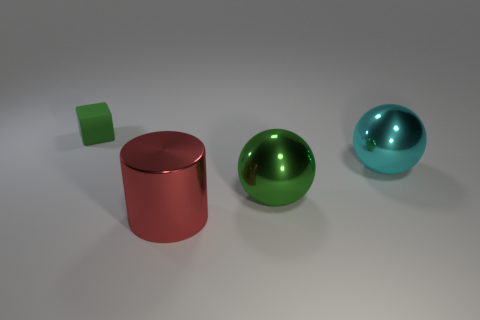Is there any other thing that has the same material as the tiny thing?
Your response must be concise. No. Is the green thing right of the tiny green block made of the same material as the red cylinder?
Offer a very short reply. Yes. There is a big thing in front of the green object on the right side of the small green rubber cube; what is its material?
Offer a very short reply. Metal. How many green matte things have the same shape as the large cyan object?
Your answer should be very brief. 0. What size is the green thing that is in front of the sphere right of the green object on the right side of the red cylinder?
Keep it short and to the point. Large. What number of purple objects are either big metallic spheres or large cylinders?
Offer a terse response. 0. There is a green thing to the right of the rubber object; does it have the same shape as the matte thing?
Provide a succinct answer. No. Is the number of green things to the right of the red cylinder greater than the number of small brown cubes?
Provide a succinct answer. Yes. How many metallic objects are the same size as the green sphere?
Your answer should be compact. 2. The metal ball that is the same color as the small object is what size?
Keep it short and to the point. Large. 